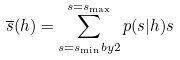Convert formula to latex. <formula><loc_0><loc_0><loc_500><loc_500>\overline { s } ( h ) = \sum _ { s = s _ { \min } b y 2 } ^ { s = s _ { \max } } p ( s | h ) s</formula> 